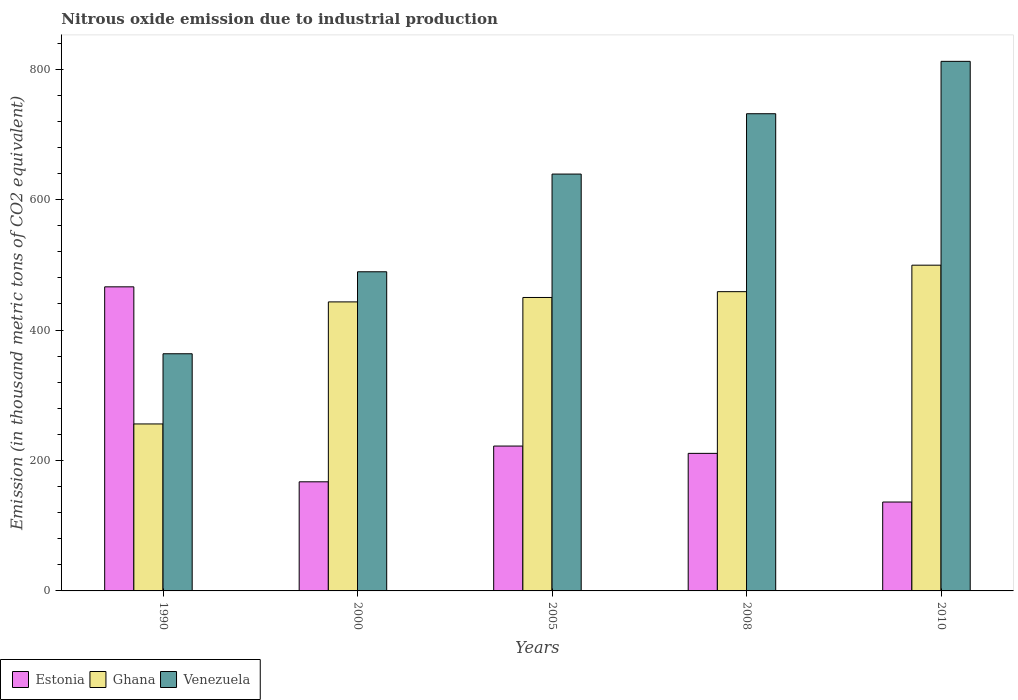Are the number of bars per tick equal to the number of legend labels?
Your answer should be compact. Yes. What is the label of the 2nd group of bars from the left?
Make the answer very short. 2000. What is the amount of nitrous oxide emitted in Ghana in 1990?
Give a very brief answer. 256. Across all years, what is the maximum amount of nitrous oxide emitted in Venezuela?
Give a very brief answer. 811.9. Across all years, what is the minimum amount of nitrous oxide emitted in Venezuela?
Provide a short and direct response. 363.6. In which year was the amount of nitrous oxide emitted in Ghana maximum?
Your answer should be compact. 2010. In which year was the amount of nitrous oxide emitted in Ghana minimum?
Your answer should be very brief. 1990. What is the total amount of nitrous oxide emitted in Venezuela in the graph?
Provide a short and direct response. 3035.5. What is the difference between the amount of nitrous oxide emitted in Ghana in 2005 and that in 2010?
Offer a terse response. -49.5. What is the difference between the amount of nitrous oxide emitted in Venezuela in 2000 and the amount of nitrous oxide emitted in Ghana in 2010?
Your answer should be compact. -10.1. What is the average amount of nitrous oxide emitted in Ghana per year?
Give a very brief answer. 421.44. In the year 2008, what is the difference between the amount of nitrous oxide emitted in Ghana and amount of nitrous oxide emitted in Venezuela?
Offer a very short reply. -272.8. What is the ratio of the amount of nitrous oxide emitted in Estonia in 2000 to that in 2010?
Keep it short and to the point. 1.23. Is the amount of nitrous oxide emitted in Venezuela in 2000 less than that in 2010?
Ensure brevity in your answer.  Yes. What is the difference between the highest and the second highest amount of nitrous oxide emitted in Venezuela?
Make the answer very short. 80.3. What is the difference between the highest and the lowest amount of nitrous oxide emitted in Ghana?
Ensure brevity in your answer.  243.4. In how many years, is the amount of nitrous oxide emitted in Ghana greater than the average amount of nitrous oxide emitted in Ghana taken over all years?
Your response must be concise. 4. Is the sum of the amount of nitrous oxide emitted in Venezuela in 2005 and 2008 greater than the maximum amount of nitrous oxide emitted in Ghana across all years?
Your answer should be very brief. Yes. What does the 2nd bar from the left in 2000 represents?
Keep it short and to the point. Ghana. Is it the case that in every year, the sum of the amount of nitrous oxide emitted in Estonia and amount of nitrous oxide emitted in Venezuela is greater than the amount of nitrous oxide emitted in Ghana?
Provide a short and direct response. Yes. Are all the bars in the graph horizontal?
Offer a very short reply. No. Are the values on the major ticks of Y-axis written in scientific E-notation?
Make the answer very short. No. Does the graph contain any zero values?
Provide a succinct answer. No. Where does the legend appear in the graph?
Offer a very short reply. Bottom left. How many legend labels are there?
Your answer should be very brief. 3. What is the title of the graph?
Offer a very short reply. Nitrous oxide emission due to industrial production. Does "Sint Maarten (Dutch part)" appear as one of the legend labels in the graph?
Offer a terse response. No. What is the label or title of the Y-axis?
Give a very brief answer. Emission (in thousand metric tons of CO2 equivalent). What is the Emission (in thousand metric tons of CO2 equivalent) in Estonia in 1990?
Your answer should be very brief. 466.2. What is the Emission (in thousand metric tons of CO2 equivalent) in Ghana in 1990?
Offer a terse response. 256. What is the Emission (in thousand metric tons of CO2 equivalent) of Venezuela in 1990?
Offer a terse response. 363.6. What is the Emission (in thousand metric tons of CO2 equivalent) in Estonia in 2000?
Provide a short and direct response. 167.3. What is the Emission (in thousand metric tons of CO2 equivalent) in Ghana in 2000?
Make the answer very short. 443.1. What is the Emission (in thousand metric tons of CO2 equivalent) of Venezuela in 2000?
Offer a terse response. 489.3. What is the Emission (in thousand metric tons of CO2 equivalent) of Estonia in 2005?
Make the answer very short. 222.1. What is the Emission (in thousand metric tons of CO2 equivalent) of Ghana in 2005?
Keep it short and to the point. 449.9. What is the Emission (in thousand metric tons of CO2 equivalent) in Venezuela in 2005?
Provide a succinct answer. 639.1. What is the Emission (in thousand metric tons of CO2 equivalent) of Estonia in 2008?
Give a very brief answer. 210.9. What is the Emission (in thousand metric tons of CO2 equivalent) in Ghana in 2008?
Your answer should be compact. 458.8. What is the Emission (in thousand metric tons of CO2 equivalent) in Venezuela in 2008?
Your response must be concise. 731.6. What is the Emission (in thousand metric tons of CO2 equivalent) in Estonia in 2010?
Your answer should be compact. 136.3. What is the Emission (in thousand metric tons of CO2 equivalent) in Ghana in 2010?
Your answer should be very brief. 499.4. What is the Emission (in thousand metric tons of CO2 equivalent) in Venezuela in 2010?
Your answer should be very brief. 811.9. Across all years, what is the maximum Emission (in thousand metric tons of CO2 equivalent) of Estonia?
Your response must be concise. 466.2. Across all years, what is the maximum Emission (in thousand metric tons of CO2 equivalent) in Ghana?
Provide a succinct answer. 499.4. Across all years, what is the maximum Emission (in thousand metric tons of CO2 equivalent) of Venezuela?
Make the answer very short. 811.9. Across all years, what is the minimum Emission (in thousand metric tons of CO2 equivalent) in Estonia?
Give a very brief answer. 136.3. Across all years, what is the minimum Emission (in thousand metric tons of CO2 equivalent) in Ghana?
Give a very brief answer. 256. Across all years, what is the minimum Emission (in thousand metric tons of CO2 equivalent) in Venezuela?
Offer a terse response. 363.6. What is the total Emission (in thousand metric tons of CO2 equivalent) in Estonia in the graph?
Your response must be concise. 1202.8. What is the total Emission (in thousand metric tons of CO2 equivalent) in Ghana in the graph?
Make the answer very short. 2107.2. What is the total Emission (in thousand metric tons of CO2 equivalent) of Venezuela in the graph?
Your answer should be compact. 3035.5. What is the difference between the Emission (in thousand metric tons of CO2 equivalent) of Estonia in 1990 and that in 2000?
Provide a short and direct response. 298.9. What is the difference between the Emission (in thousand metric tons of CO2 equivalent) in Ghana in 1990 and that in 2000?
Your answer should be compact. -187.1. What is the difference between the Emission (in thousand metric tons of CO2 equivalent) of Venezuela in 1990 and that in 2000?
Provide a short and direct response. -125.7. What is the difference between the Emission (in thousand metric tons of CO2 equivalent) in Estonia in 1990 and that in 2005?
Give a very brief answer. 244.1. What is the difference between the Emission (in thousand metric tons of CO2 equivalent) in Ghana in 1990 and that in 2005?
Provide a short and direct response. -193.9. What is the difference between the Emission (in thousand metric tons of CO2 equivalent) in Venezuela in 1990 and that in 2005?
Keep it short and to the point. -275.5. What is the difference between the Emission (in thousand metric tons of CO2 equivalent) of Estonia in 1990 and that in 2008?
Make the answer very short. 255.3. What is the difference between the Emission (in thousand metric tons of CO2 equivalent) in Ghana in 1990 and that in 2008?
Your answer should be compact. -202.8. What is the difference between the Emission (in thousand metric tons of CO2 equivalent) of Venezuela in 1990 and that in 2008?
Offer a very short reply. -368. What is the difference between the Emission (in thousand metric tons of CO2 equivalent) of Estonia in 1990 and that in 2010?
Ensure brevity in your answer.  329.9. What is the difference between the Emission (in thousand metric tons of CO2 equivalent) of Ghana in 1990 and that in 2010?
Keep it short and to the point. -243.4. What is the difference between the Emission (in thousand metric tons of CO2 equivalent) in Venezuela in 1990 and that in 2010?
Offer a terse response. -448.3. What is the difference between the Emission (in thousand metric tons of CO2 equivalent) in Estonia in 2000 and that in 2005?
Your response must be concise. -54.8. What is the difference between the Emission (in thousand metric tons of CO2 equivalent) of Ghana in 2000 and that in 2005?
Ensure brevity in your answer.  -6.8. What is the difference between the Emission (in thousand metric tons of CO2 equivalent) of Venezuela in 2000 and that in 2005?
Offer a terse response. -149.8. What is the difference between the Emission (in thousand metric tons of CO2 equivalent) in Estonia in 2000 and that in 2008?
Provide a succinct answer. -43.6. What is the difference between the Emission (in thousand metric tons of CO2 equivalent) of Ghana in 2000 and that in 2008?
Provide a short and direct response. -15.7. What is the difference between the Emission (in thousand metric tons of CO2 equivalent) in Venezuela in 2000 and that in 2008?
Ensure brevity in your answer.  -242.3. What is the difference between the Emission (in thousand metric tons of CO2 equivalent) of Estonia in 2000 and that in 2010?
Provide a short and direct response. 31. What is the difference between the Emission (in thousand metric tons of CO2 equivalent) of Ghana in 2000 and that in 2010?
Your answer should be very brief. -56.3. What is the difference between the Emission (in thousand metric tons of CO2 equivalent) of Venezuela in 2000 and that in 2010?
Keep it short and to the point. -322.6. What is the difference between the Emission (in thousand metric tons of CO2 equivalent) of Venezuela in 2005 and that in 2008?
Your answer should be very brief. -92.5. What is the difference between the Emission (in thousand metric tons of CO2 equivalent) of Estonia in 2005 and that in 2010?
Offer a terse response. 85.8. What is the difference between the Emission (in thousand metric tons of CO2 equivalent) in Ghana in 2005 and that in 2010?
Make the answer very short. -49.5. What is the difference between the Emission (in thousand metric tons of CO2 equivalent) of Venezuela in 2005 and that in 2010?
Offer a very short reply. -172.8. What is the difference between the Emission (in thousand metric tons of CO2 equivalent) in Estonia in 2008 and that in 2010?
Provide a short and direct response. 74.6. What is the difference between the Emission (in thousand metric tons of CO2 equivalent) in Ghana in 2008 and that in 2010?
Offer a very short reply. -40.6. What is the difference between the Emission (in thousand metric tons of CO2 equivalent) of Venezuela in 2008 and that in 2010?
Offer a very short reply. -80.3. What is the difference between the Emission (in thousand metric tons of CO2 equivalent) in Estonia in 1990 and the Emission (in thousand metric tons of CO2 equivalent) in Ghana in 2000?
Offer a very short reply. 23.1. What is the difference between the Emission (in thousand metric tons of CO2 equivalent) of Estonia in 1990 and the Emission (in thousand metric tons of CO2 equivalent) of Venezuela in 2000?
Offer a very short reply. -23.1. What is the difference between the Emission (in thousand metric tons of CO2 equivalent) in Ghana in 1990 and the Emission (in thousand metric tons of CO2 equivalent) in Venezuela in 2000?
Your answer should be compact. -233.3. What is the difference between the Emission (in thousand metric tons of CO2 equivalent) of Estonia in 1990 and the Emission (in thousand metric tons of CO2 equivalent) of Venezuela in 2005?
Ensure brevity in your answer.  -172.9. What is the difference between the Emission (in thousand metric tons of CO2 equivalent) of Ghana in 1990 and the Emission (in thousand metric tons of CO2 equivalent) of Venezuela in 2005?
Provide a short and direct response. -383.1. What is the difference between the Emission (in thousand metric tons of CO2 equivalent) in Estonia in 1990 and the Emission (in thousand metric tons of CO2 equivalent) in Ghana in 2008?
Your answer should be very brief. 7.4. What is the difference between the Emission (in thousand metric tons of CO2 equivalent) in Estonia in 1990 and the Emission (in thousand metric tons of CO2 equivalent) in Venezuela in 2008?
Your response must be concise. -265.4. What is the difference between the Emission (in thousand metric tons of CO2 equivalent) of Ghana in 1990 and the Emission (in thousand metric tons of CO2 equivalent) of Venezuela in 2008?
Offer a terse response. -475.6. What is the difference between the Emission (in thousand metric tons of CO2 equivalent) of Estonia in 1990 and the Emission (in thousand metric tons of CO2 equivalent) of Ghana in 2010?
Your answer should be compact. -33.2. What is the difference between the Emission (in thousand metric tons of CO2 equivalent) of Estonia in 1990 and the Emission (in thousand metric tons of CO2 equivalent) of Venezuela in 2010?
Keep it short and to the point. -345.7. What is the difference between the Emission (in thousand metric tons of CO2 equivalent) of Ghana in 1990 and the Emission (in thousand metric tons of CO2 equivalent) of Venezuela in 2010?
Ensure brevity in your answer.  -555.9. What is the difference between the Emission (in thousand metric tons of CO2 equivalent) of Estonia in 2000 and the Emission (in thousand metric tons of CO2 equivalent) of Ghana in 2005?
Give a very brief answer. -282.6. What is the difference between the Emission (in thousand metric tons of CO2 equivalent) in Estonia in 2000 and the Emission (in thousand metric tons of CO2 equivalent) in Venezuela in 2005?
Offer a terse response. -471.8. What is the difference between the Emission (in thousand metric tons of CO2 equivalent) of Ghana in 2000 and the Emission (in thousand metric tons of CO2 equivalent) of Venezuela in 2005?
Provide a succinct answer. -196. What is the difference between the Emission (in thousand metric tons of CO2 equivalent) in Estonia in 2000 and the Emission (in thousand metric tons of CO2 equivalent) in Ghana in 2008?
Ensure brevity in your answer.  -291.5. What is the difference between the Emission (in thousand metric tons of CO2 equivalent) of Estonia in 2000 and the Emission (in thousand metric tons of CO2 equivalent) of Venezuela in 2008?
Offer a terse response. -564.3. What is the difference between the Emission (in thousand metric tons of CO2 equivalent) in Ghana in 2000 and the Emission (in thousand metric tons of CO2 equivalent) in Venezuela in 2008?
Provide a short and direct response. -288.5. What is the difference between the Emission (in thousand metric tons of CO2 equivalent) of Estonia in 2000 and the Emission (in thousand metric tons of CO2 equivalent) of Ghana in 2010?
Provide a short and direct response. -332.1. What is the difference between the Emission (in thousand metric tons of CO2 equivalent) in Estonia in 2000 and the Emission (in thousand metric tons of CO2 equivalent) in Venezuela in 2010?
Keep it short and to the point. -644.6. What is the difference between the Emission (in thousand metric tons of CO2 equivalent) of Ghana in 2000 and the Emission (in thousand metric tons of CO2 equivalent) of Venezuela in 2010?
Provide a short and direct response. -368.8. What is the difference between the Emission (in thousand metric tons of CO2 equivalent) in Estonia in 2005 and the Emission (in thousand metric tons of CO2 equivalent) in Ghana in 2008?
Provide a succinct answer. -236.7. What is the difference between the Emission (in thousand metric tons of CO2 equivalent) in Estonia in 2005 and the Emission (in thousand metric tons of CO2 equivalent) in Venezuela in 2008?
Provide a succinct answer. -509.5. What is the difference between the Emission (in thousand metric tons of CO2 equivalent) of Ghana in 2005 and the Emission (in thousand metric tons of CO2 equivalent) of Venezuela in 2008?
Give a very brief answer. -281.7. What is the difference between the Emission (in thousand metric tons of CO2 equivalent) of Estonia in 2005 and the Emission (in thousand metric tons of CO2 equivalent) of Ghana in 2010?
Provide a short and direct response. -277.3. What is the difference between the Emission (in thousand metric tons of CO2 equivalent) in Estonia in 2005 and the Emission (in thousand metric tons of CO2 equivalent) in Venezuela in 2010?
Provide a short and direct response. -589.8. What is the difference between the Emission (in thousand metric tons of CO2 equivalent) of Ghana in 2005 and the Emission (in thousand metric tons of CO2 equivalent) of Venezuela in 2010?
Your answer should be compact. -362. What is the difference between the Emission (in thousand metric tons of CO2 equivalent) in Estonia in 2008 and the Emission (in thousand metric tons of CO2 equivalent) in Ghana in 2010?
Your response must be concise. -288.5. What is the difference between the Emission (in thousand metric tons of CO2 equivalent) in Estonia in 2008 and the Emission (in thousand metric tons of CO2 equivalent) in Venezuela in 2010?
Offer a very short reply. -601. What is the difference between the Emission (in thousand metric tons of CO2 equivalent) in Ghana in 2008 and the Emission (in thousand metric tons of CO2 equivalent) in Venezuela in 2010?
Your answer should be very brief. -353.1. What is the average Emission (in thousand metric tons of CO2 equivalent) of Estonia per year?
Provide a succinct answer. 240.56. What is the average Emission (in thousand metric tons of CO2 equivalent) of Ghana per year?
Your answer should be compact. 421.44. What is the average Emission (in thousand metric tons of CO2 equivalent) in Venezuela per year?
Make the answer very short. 607.1. In the year 1990, what is the difference between the Emission (in thousand metric tons of CO2 equivalent) in Estonia and Emission (in thousand metric tons of CO2 equivalent) in Ghana?
Your response must be concise. 210.2. In the year 1990, what is the difference between the Emission (in thousand metric tons of CO2 equivalent) in Estonia and Emission (in thousand metric tons of CO2 equivalent) in Venezuela?
Your response must be concise. 102.6. In the year 1990, what is the difference between the Emission (in thousand metric tons of CO2 equivalent) of Ghana and Emission (in thousand metric tons of CO2 equivalent) of Venezuela?
Ensure brevity in your answer.  -107.6. In the year 2000, what is the difference between the Emission (in thousand metric tons of CO2 equivalent) of Estonia and Emission (in thousand metric tons of CO2 equivalent) of Ghana?
Make the answer very short. -275.8. In the year 2000, what is the difference between the Emission (in thousand metric tons of CO2 equivalent) in Estonia and Emission (in thousand metric tons of CO2 equivalent) in Venezuela?
Keep it short and to the point. -322. In the year 2000, what is the difference between the Emission (in thousand metric tons of CO2 equivalent) of Ghana and Emission (in thousand metric tons of CO2 equivalent) of Venezuela?
Provide a succinct answer. -46.2. In the year 2005, what is the difference between the Emission (in thousand metric tons of CO2 equivalent) of Estonia and Emission (in thousand metric tons of CO2 equivalent) of Ghana?
Make the answer very short. -227.8. In the year 2005, what is the difference between the Emission (in thousand metric tons of CO2 equivalent) in Estonia and Emission (in thousand metric tons of CO2 equivalent) in Venezuela?
Provide a short and direct response. -417. In the year 2005, what is the difference between the Emission (in thousand metric tons of CO2 equivalent) of Ghana and Emission (in thousand metric tons of CO2 equivalent) of Venezuela?
Give a very brief answer. -189.2. In the year 2008, what is the difference between the Emission (in thousand metric tons of CO2 equivalent) in Estonia and Emission (in thousand metric tons of CO2 equivalent) in Ghana?
Give a very brief answer. -247.9. In the year 2008, what is the difference between the Emission (in thousand metric tons of CO2 equivalent) in Estonia and Emission (in thousand metric tons of CO2 equivalent) in Venezuela?
Give a very brief answer. -520.7. In the year 2008, what is the difference between the Emission (in thousand metric tons of CO2 equivalent) in Ghana and Emission (in thousand metric tons of CO2 equivalent) in Venezuela?
Your answer should be very brief. -272.8. In the year 2010, what is the difference between the Emission (in thousand metric tons of CO2 equivalent) in Estonia and Emission (in thousand metric tons of CO2 equivalent) in Ghana?
Offer a very short reply. -363.1. In the year 2010, what is the difference between the Emission (in thousand metric tons of CO2 equivalent) in Estonia and Emission (in thousand metric tons of CO2 equivalent) in Venezuela?
Your response must be concise. -675.6. In the year 2010, what is the difference between the Emission (in thousand metric tons of CO2 equivalent) in Ghana and Emission (in thousand metric tons of CO2 equivalent) in Venezuela?
Your response must be concise. -312.5. What is the ratio of the Emission (in thousand metric tons of CO2 equivalent) in Estonia in 1990 to that in 2000?
Ensure brevity in your answer.  2.79. What is the ratio of the Emission (in thousand metric tons of CO2 equivalent) in Ghana in 1990 to that in 2000?
Your answer should be very brief. 0.58. What is the ratio of the Emission (in thousand metric tons of CO2 equivalent) of Venezuela in 1990 to that in 2000?
Ensure brevity in your answer.  0.74. What is the ratio of the Emission (in thousand metric tons of CO2 equivalent) of Estonia in 1990 to that in 2005?
Provide a short and direct response. 2.1. What is the ratio of the Emission (in thousand metric tons of CO2 equivalent) in Ghana in 1990 to that in 2005?
Offer a very short reply. 0.57. What is the ratio of the Emission (in thousand metric tons of CO2 equivalent) in Venezuela in 1990 to that in 2005?
Your answer should be compact. 0.57. What is the ratio of the Emission (in thousand metric tons of CO2 equivalent) in Estonia in 1990 to that in 2008?
Give a very brief answer. 2.21. What is the ratio of the Emission (in thousand metric tons of CO2 equivalent) in Ghana in 1990 to that in 2008?
Provide a succinct answer. 0.56. What is the ratio of the Emission (in thousand metric tons of CO2 equivalent) in Venezuela in 1990 to that in 2008?
Your answer should be compact. 0.5. What is the ratio of the Emission (in thousand metric tons of CO2 equivalent) in Estonia in 1990 to that in 2010?
Your response must be concise. 3.42. What is the ratio of the Emission (in thousand metric tons of CO2 equivalent) in Ghana in 1990 to that in 2010?
Give a very brief answer. 0.51. What is the ratio of the Emission (in thousand metric tons of CO2 equivalent) of Venezuela in 1990 to that in 2010?
Make the answer very short. 0.45. What is the ratio of the Emission (in thousand metric tons of CO2 equivalent) of Estonia in 2000 to that in 2005?
Provide a succinct answer. 0.75. What is the ratio of the Emission (in thousand metric tons of CO2 equivalent) of Ghana in 2000 to that in 2005?
Your response must be concise. 0.98. What is the ratio of the Emission (in thousand metric tons of CO2 equivalent) of Venezuela in 2000 to that in 2005?
Make the answer very short. 0.77. What is the ratio of the Emission (in thousand metric tons of CO2 equivalent) in Estonia in 2000 to that in 2008?
Give a very brief answer. 0.79. What is the ratio of the Emission (in thousand metric tons of CO2 equivalent) of Ghana in 2000 to that in 2008?
Give a very brief answer. 0.97. What is the ratio of the Emission (in thousand metric tons of CO2 equivalent) of Venezuela in 2000 to that in 2008?
Give a very brief answer. 0.67. What is the ratio of the Emission (in thousand metric tons of CO2 equivalent) of Estonia in 2000 to that in 2010?
Offer a terse response. 1.23. What is the ratio of the Emission (in thousand metric tons of CO2 equivalent) in Ghana in 2000 to that in 2010?
Make the answer very short. 0.89. What is the ratio of the Emission (in thousand metric tons of CO2 equivalent) of Venezuela in 2000 to that in 2010?
Provide a succinct answer. 0.6. What is the ratio of the Emission (in thousand metric tons of CO2 equivalent) in Estonia in 2005 to that in 2008?
Your answer should be compact. 1.05. What is the ratio of the Emission (in thousand metric tons of CO2 equivalent) of Ghana in 2005 to that in 2008?
Your response must be concise. 0.98. What is the ratio of the Emission (in thousand metric tons of CO2 equivalent) of Venezuela in 2005 to that in 2008?
Offer a terse response. 0.87. What is the ratio of the Emission (in thousand metric tons of CO2 equivalent) in Estonia in 2005 to that in 2010?
Provide a succinct answer. 1.63. What is the ratio of the Emission (in thousand metric tons of CO2 equivalent) of Ghana in 2005 to that in 2010?
Your answer should be compact. 0.9. What is the ratio of the Emission (in thousand metric tons of CO2 equivalent) in Venezuela in 2005 to that in 2010?
Provide a succinct answer. 0.79. What is the ratio of the Emission (in thousand metric tons of CO2 equivalent) of Estonia in 2008 to that in 2010?
Your response must be concise. 1.55. What is the ratio of the Emission (in thousand metric tons of CO2 equivalent) of Ghana in 2008 to that in 2010?
Your response must be concise. 0.92. What is the ratio of the Emission (in thousand metric tons of CO2 equivalent) in Venezuela in 2008 to that in 2010?
Your answer should be compact. 0.9. What is the difference between the highest and the second highest Emission (in thousand metric tons of CO2 equivalent) of Estonia?
Give a very brief answer. 244.1. What is the difference between the highest and the second highest Emission (in thousand metric tons of CO2 equivalent) in Ghana?
Provide a short and direct response. 40.6. What is the difference between the highest and the second highest Emission (in thousand metric tons of CO2 equivalent) in Venezuela?
Keep it short and to the point. 80.3. What is the difference between the highest and the lowest Emission (in thousand metric tons of CO2 equivalent) of Estonia?
Offer a terse response. 329.9. What is the difference between the highest and the lowest Emission (in thousand metric tons of CO2 equivalent) of Ghana?
Provide a succinct answer. 243.4. What is the difference between the highest and the lowest Emission (in thousand metric tons of CO2 equivalent) in Venezuela?
Provide a short and direct response. 448.3. 